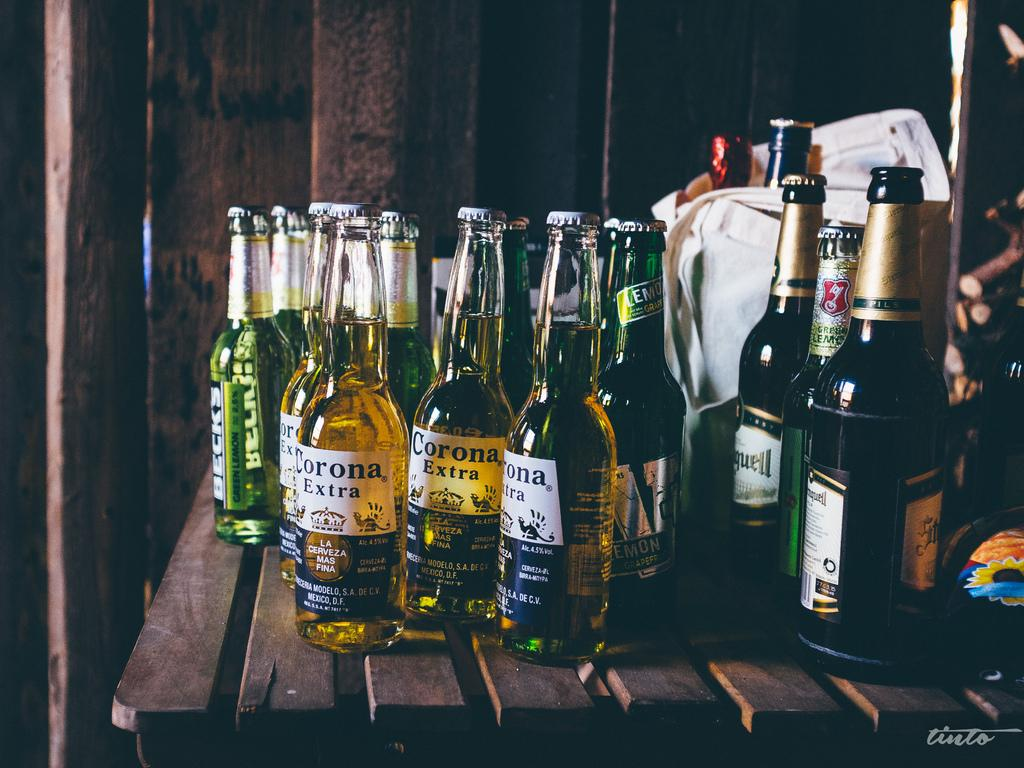<image>
Describe the image concisely. Bottles of beer, including Corona Extra, are sitting on a table. 